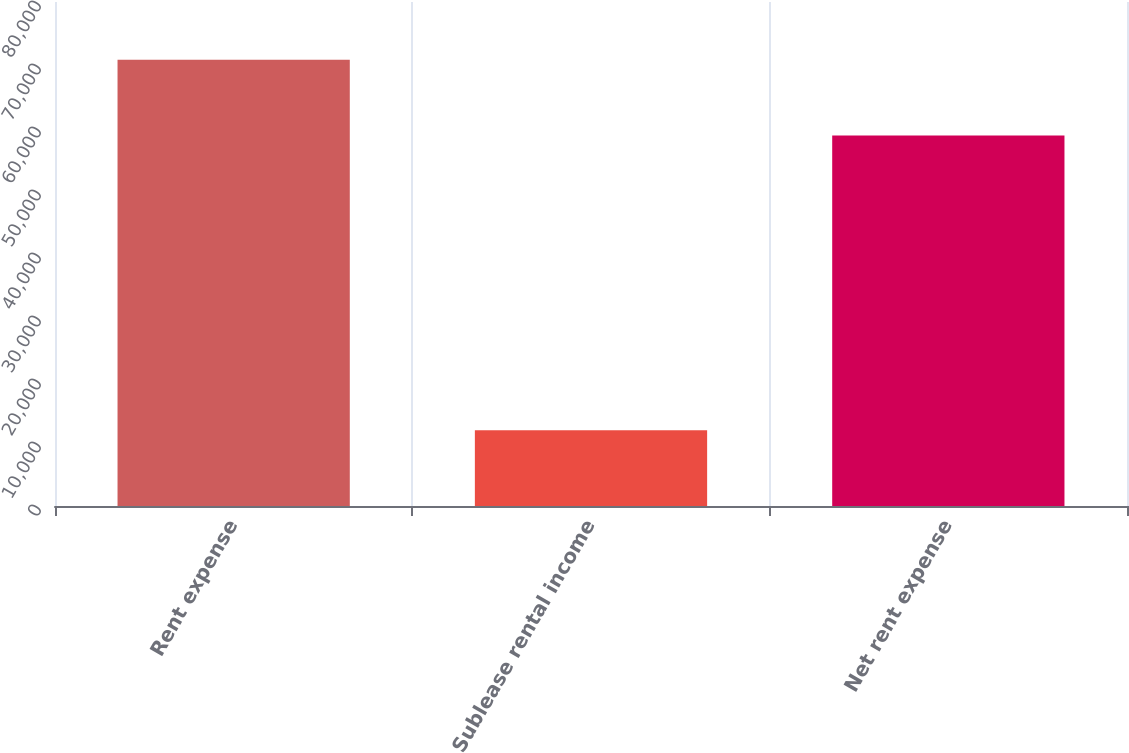Convert chart. <chart><loc_0><loc_0><loc_500><loc_500><bar_chart><fcel>Rent expense<fcel>Sublease rental income<fcel>Net rent expense<nl><fcel>70815<fcel>12007<fcel>58808<nl></chart> 